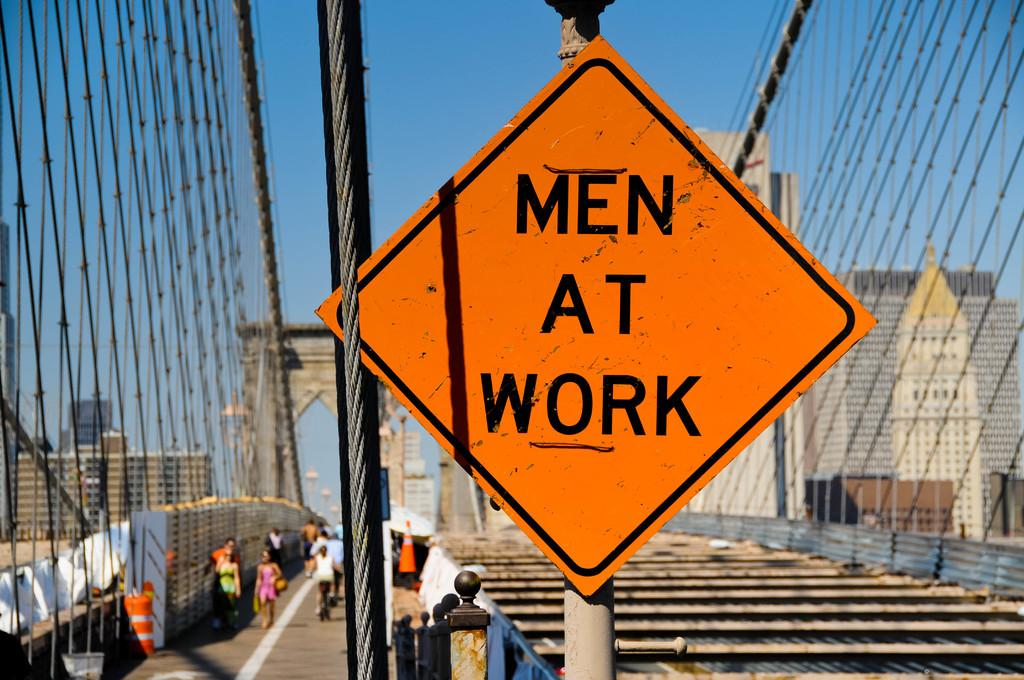<image>
Share a concise interpretation of the image provided. A sign on a bridge that looks under construction saying Men At Work. 